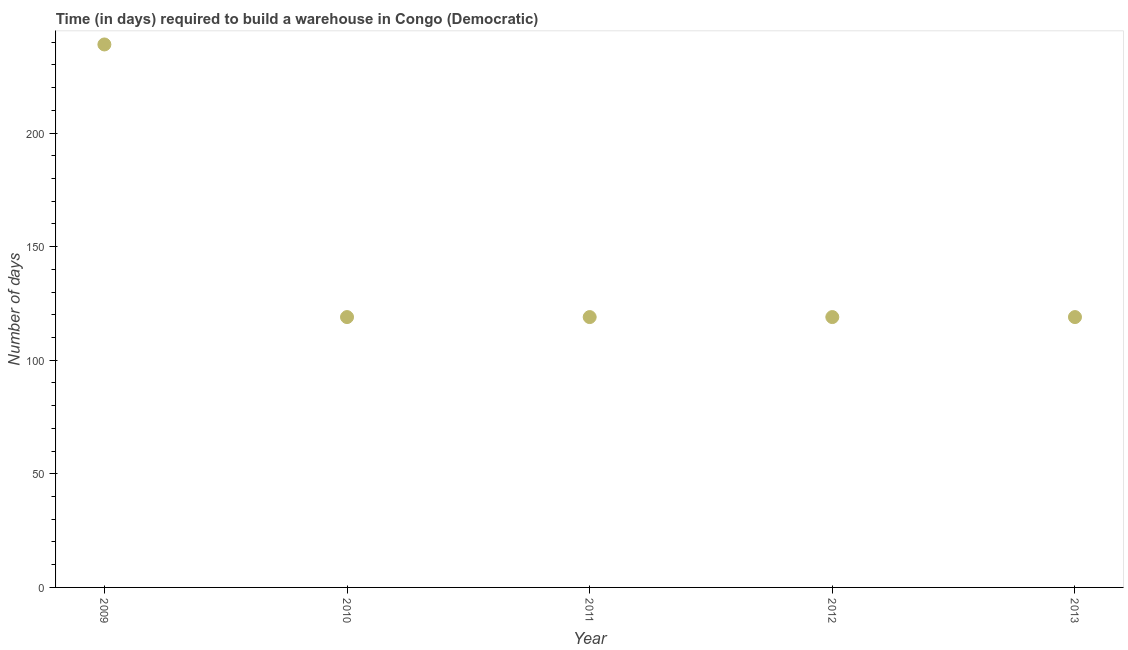What is the time required to build a warehouse in 2011?
Ensure brevity in your answer.  119. Across all years, what is the maximum time required to build a warehouse?
Offer a very short reply. 239. Across all years, what is the minimum time required to build a warehouse?
Provide a short and direct response. 119. In which year was the time required to build a warehouse maximum?
Offer a very short reply. 2009. What is the sum of the time required to build a warehouse?
Your response must be concise. 715. What is the average time required to build a warehouse per year?
Keep it short and to the point. 143. What is the median time required to build a warehouse?
Offer a very short reply. 119. In how many years, is the time required to build a warehouse greater than 160 days?
Your answer should be very brief. 1. Do a majority of the years between 2012 and 2011 (inclusive) have time required to build a warehouse greater than 50 days?
Provide a short and direct response. No. What is the ratio of the time required to build a warehouse in 2009 to that in 2011?
Make the answer very short. 2.01. What is the difference between the highest and the second highest time required to build a warehouse?
Ensure brevity in your answer.  120. What is the difference between the highest and the lowest time required to build a warehouse?
Keep it short and to the point. 120. How many dotlines are there?
Your answer should be very brief. 1. What is the difference between two consecutive major ticks on the Y-axis?
Keep it short and to the point. 50. Are the values on the major ticks of Y-axis written in scientific E-notation?
Provide a succinct answer. No. Does the graph contain any zero values?
Make the answer very short. No. What is the title of the graph?
Keep it short and to the point. Time (in days) required to build a warehouse in Congo (Democratic). What is the label or title of the X-axis?
Keep it short and to the point. Year. What is the label or title of the Y-axis?
Your answer should be compact. Number of days. What is the Number of days in 2009?
Your answer should be compact. 239. What is the Number of days in 2010?
Offer a terse response. 119. What is the Number of days in 2011?
Your answer should be compact. 119. What is the Number of days in 2012?
Ensure brevity in your answer.  119. What is the Number of days in 2013?
Provide a short and direct response. 119. What is the difference between the Number of days in 2009 and 2010?
Give a very brief answer. 120. What is the difference between the Number of days in 2009 and 2011?
Ensure brevity in your answer.  120. What is the difference between the Number of days in 2009 and 2012?
Your answer should be very brief. 120. What is the difference between the Number of days in 2009 and 2013?
Offer a very short reply. 120. What is the difference between the Number of days in 2010 and 2011?
Provide a succinct answer. 0. What is the difference between the Number of days in 2010 and 2012?
Make the answer very short. 0. What is the difference between the Number of days in 2012 and 2013?
Keep it short and to the point. 0. What is the ratio of the Number of days in 2009 to that in 2010?
Offer a terse response. 2.01. What is the ratio of the Number of days in 2009 to that in 2011?
Make the answer very short. 2.01. What is the ratio of the Number of days in 2009 to that in 2012?
Offer a terse response. 2.01. What is the ratio of the Number of days in 2009 to that in 2013?
Your response must be concise. 2.01. What is the ratio of the Number of days in 2010 to that in 2011?
Provide a short and direct response. 1. What is the ratio of the Number of days in 2010 to that in 2012?
Provide a succinct answer. 1. What is the ratio of the Number of days in 2011 to that in 2012?
Make the answer very short. 1. What is the ratio of the Number of days in 2011 to that in 2013?
Your answer should be compact. 1. 